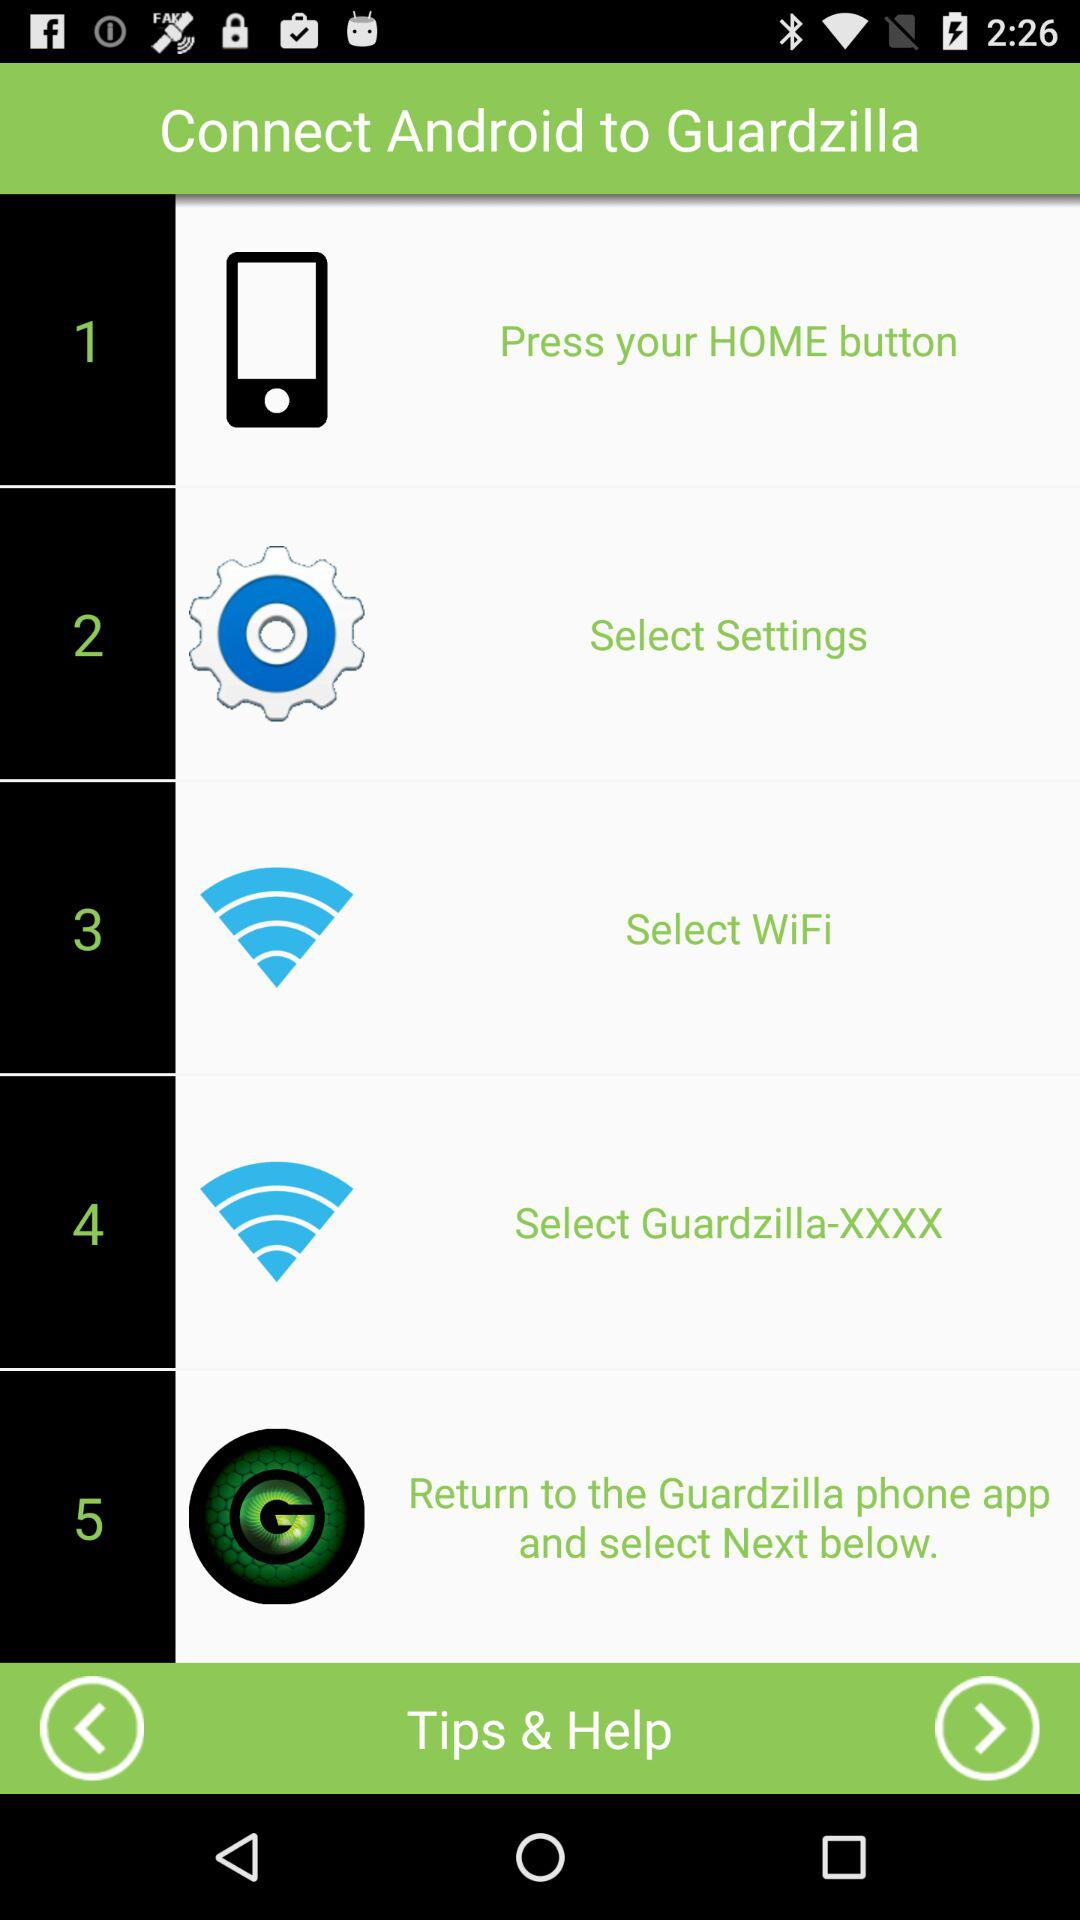How many steps are there in the process?
Answer the question using a single word or phrase. 5 